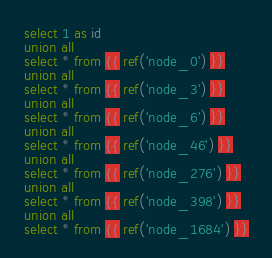<code> <loc_0><loc_0><loc_500><loc_500><_SQL_>select 1 as id
union all
select * from {{ ref('node_0') }}
union all
select * from {{ ref('node_3') }}
union all
select * from {{ ref('node_6') }}
union all
select * from {{ ref('node_46') }}
union all
select * from {{ ref('node_276') }}
union all
select * from {{ ref('node_398') }}
union all
select * from {{ ref('node_1684') }}
</code> 